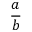Convert formula to latex. <formula><loc_0><loc_0><loc_500><loc_500>\frac { a } { b }</formula> 